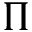Convert formula to latex. <formula><loc_0><loc_0><loc_500><loc_500>\Pi</formula> 